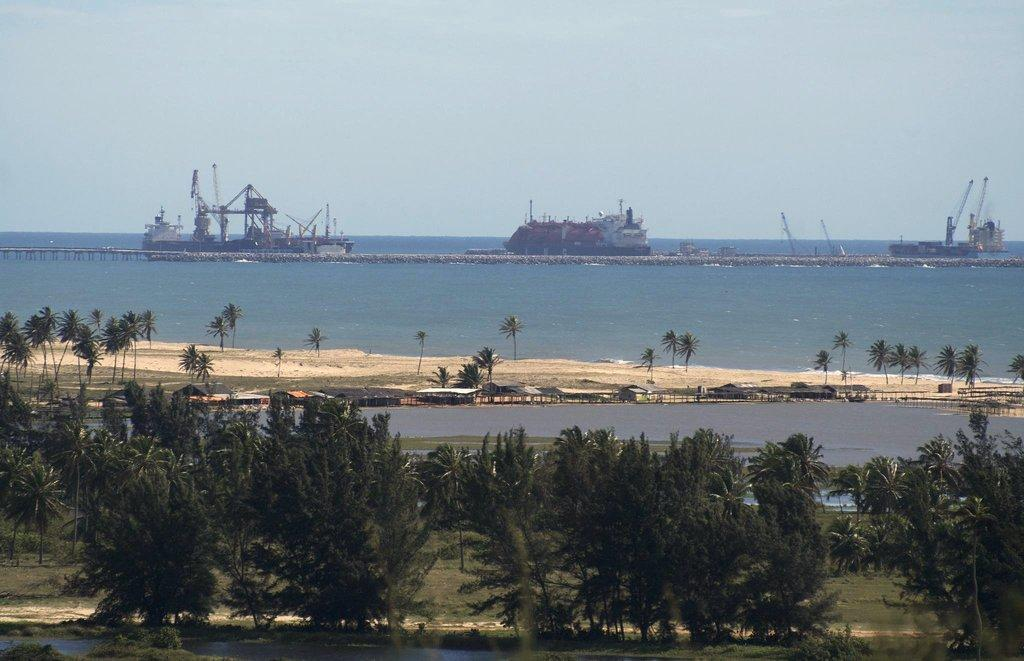What is in the foreground of the image? In the foreground of the image, there are trees, grass, water, and a bridge. Can you describe the vegetation in the foreground? The vegetation in the foreground consists of trees. What else can be seen in the foreground besides the vegetation? There is also grass and a bridge visible in the foreground. What is visible in the background of the image? In the background of the image, there are boats and the sky. What might be the location of the image? The image may have been taken near the ocean, given the presence of water and boats. What type of brass instrument is being played during the protest in the image? There is no brass instrument or protest present in the image; it features a natural scene with trees, grass, water, a bridge, boats, and the sky. 